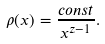Convert formula to latex. <formula><loc_0><loc_0><loc_500><loc_500>\rho ( x ) = \frac { c o n s t } { x ^ { z - 1 } } .</formula> 